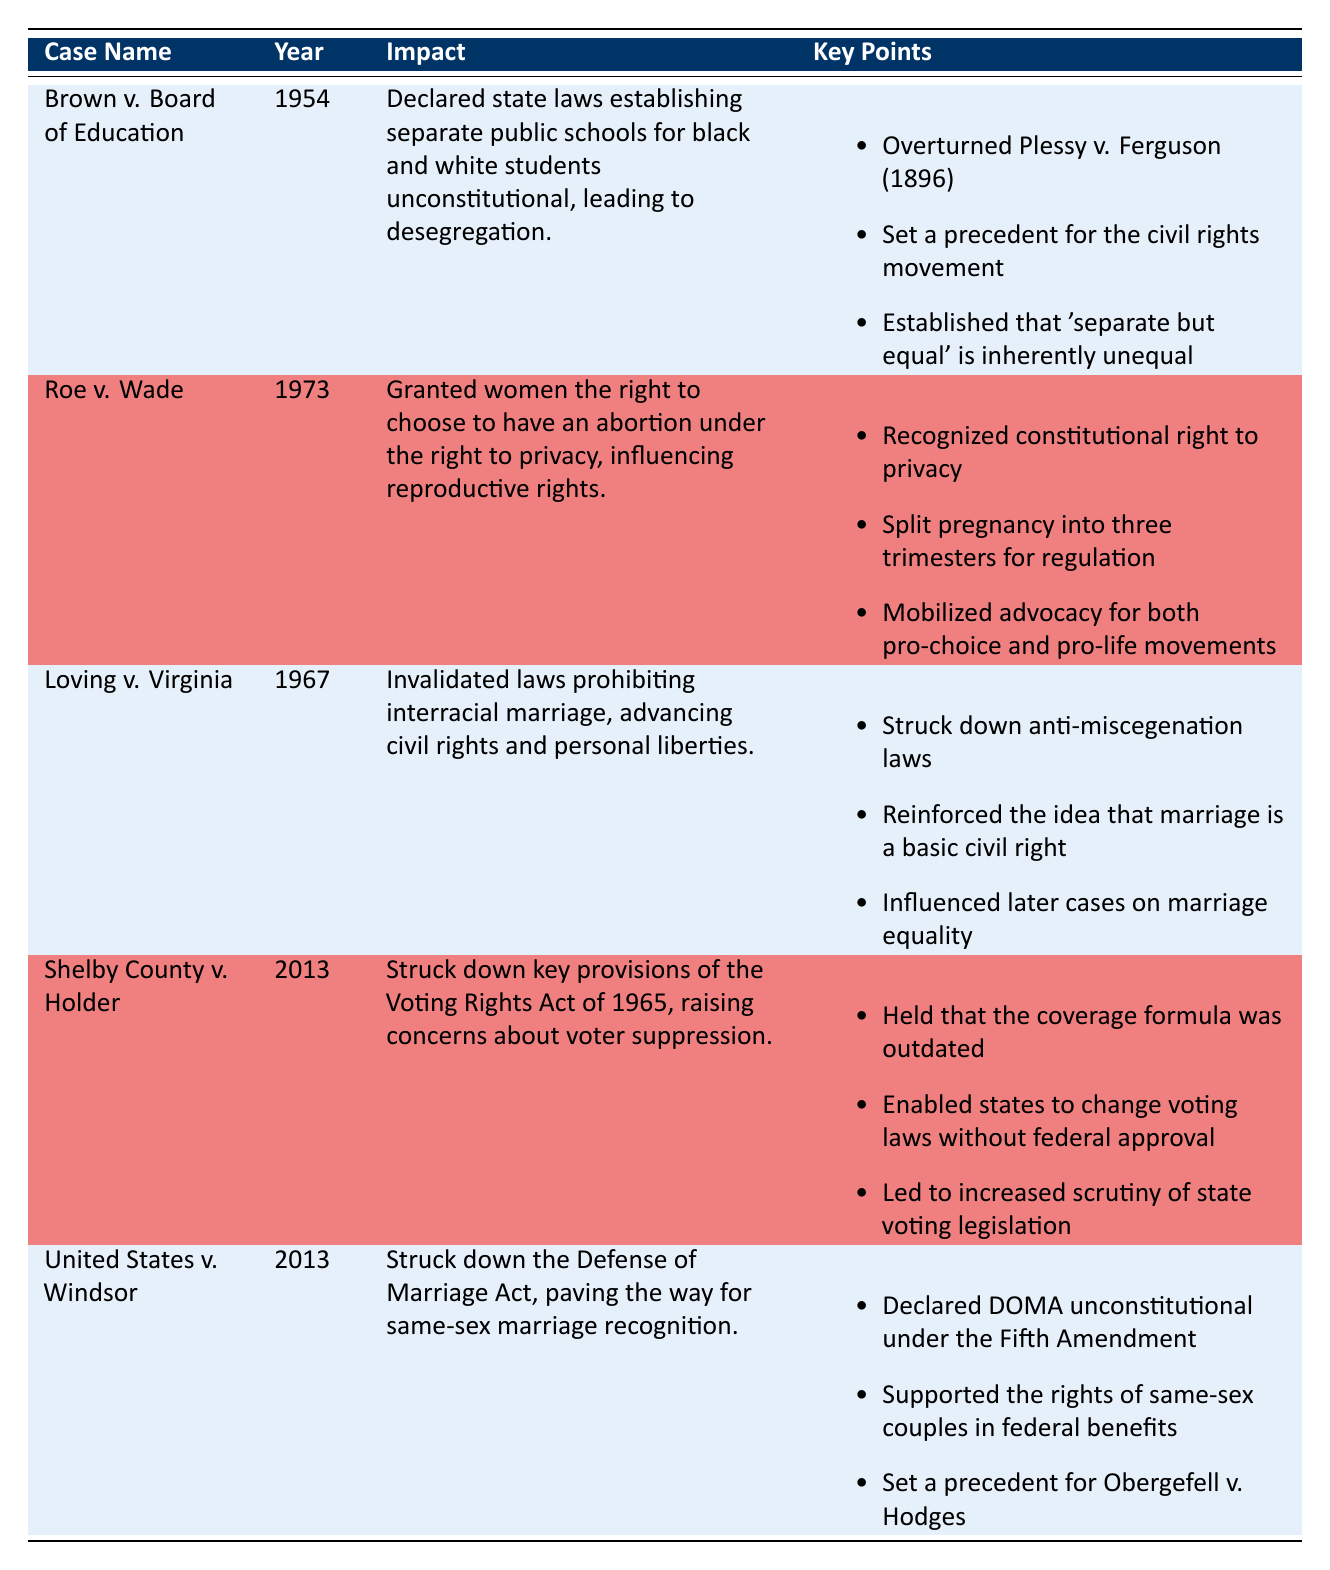What year was Brown v. Board of Education decided? The year of the decision for Brown v. Board of Education is directly listed in the table under the 'Year' column.
Answer: 1954 What impact did Roe v. Wade have on reproductive rights? Roe v. Wade granted women the right to choose to have an abortion under the right to privacy, which is explicitly mentioned in the 'Impact' column.
Answer: It influenced reproductive rights How many landmark decisions in the table were made in the 2010s? The years provided for the decisions are 1954, 1973, 1967, and two from 2013. Counting the 2013 cases (Shelby County v. Holder and United States v. Windsor) gives a total of two decisions made in the 2010s.
Answer: 2 Is it true that Brown v. Board of Education established that "separate but equal" is inherently unequal? This fact is explicitly stated in the 'Key Points' section for Brown v. Board of Education in the table.
Answer: Yes Which case directly influenced later cases on marriage equality? The table indicates under the 'Key Points' for Loving v. Virginia that it influenced later cases on marriage equality, thus answering the question.
Answer: Loving v. Virginia 